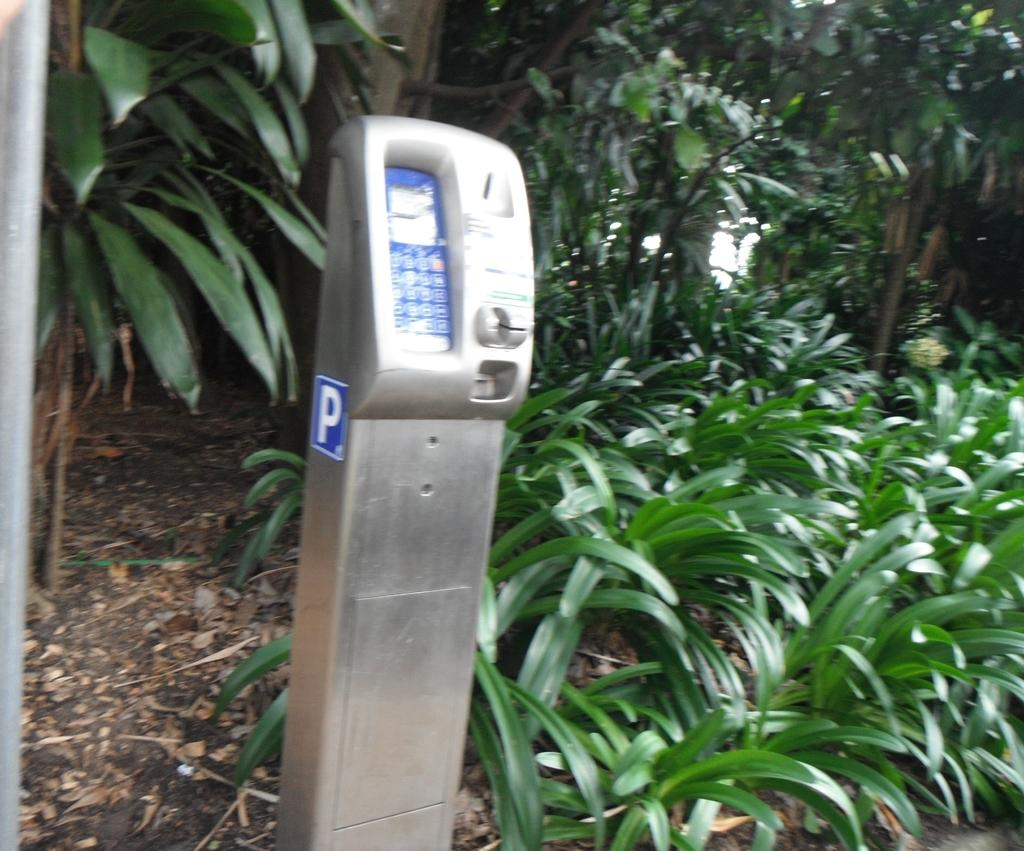What type of vegetation can be seen in the image? There are plants in the image. What is the color of the leaves on the plants? There are green leaves in the image. What is present on the ground in the image? There are dried leaves on the ground. What type of machine is visible in the image? The image features a parking machine. What type of corn can be seen growing in the image? There is no corn present in the image. How are the sticks arranged in the image? There are no sticks present in the image. 